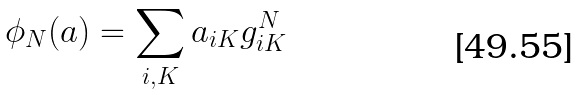Convert formula to latex. <formula><loc_0><loc_0><loc_500><loc_500>\phi _ { N } ( a ) = \sum _ { i , K } a _ { i K } g _ { i K } ^ { N }</formula> 